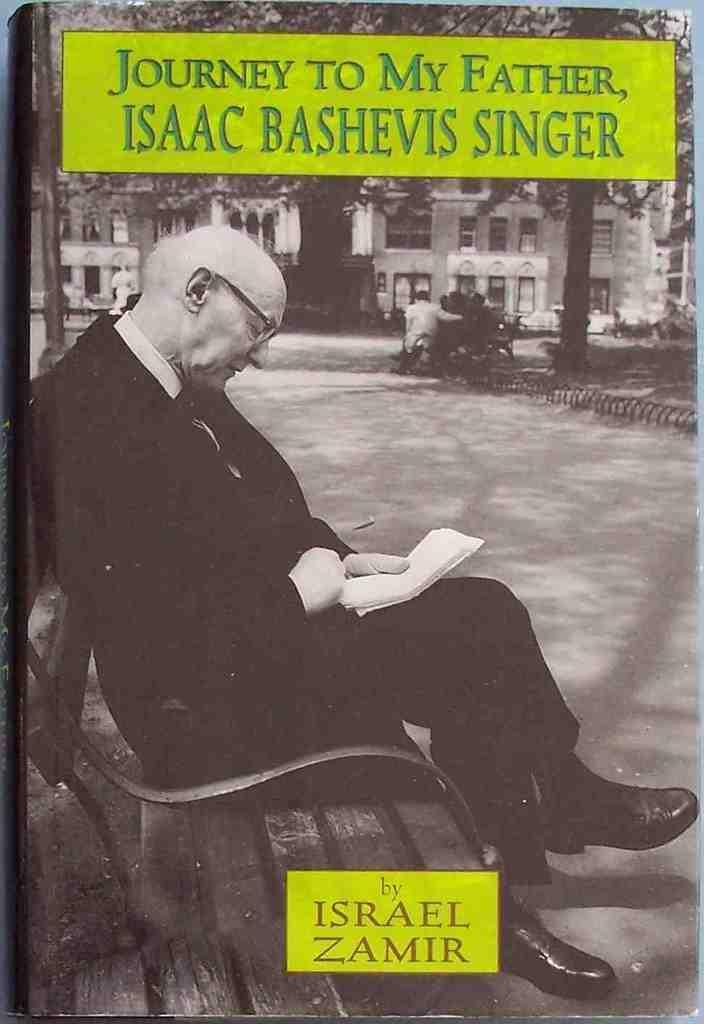Describe this image in one or two sentences. In this image on the left side there is one man who is sitting on a bench, and he is holding some papers and in the background there are some houses and trees and there are some other persons who are sitting on bench. On the top of the image and bottom of the image there is some text written, at the bottom there is a walkway. 